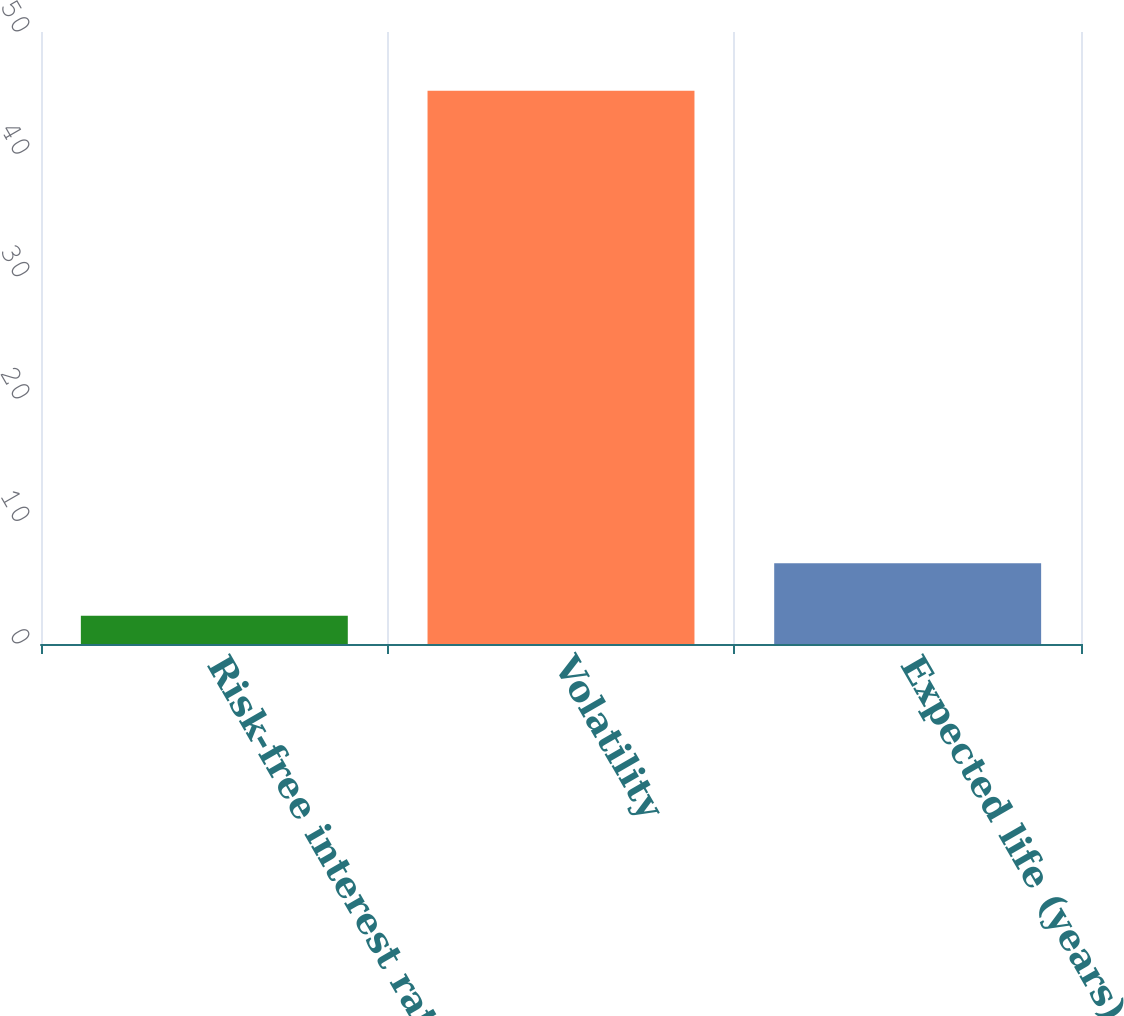Convert chart. <chart><loc_0><loc_0><loc_500><loc_500><bar_chart><fcel>Risk-free interest rate<fcel>Volatility<fcel>Expected life (years)<nl><fcel>2.3<fcel>45.2<fcel>6.59<nl></chart> 